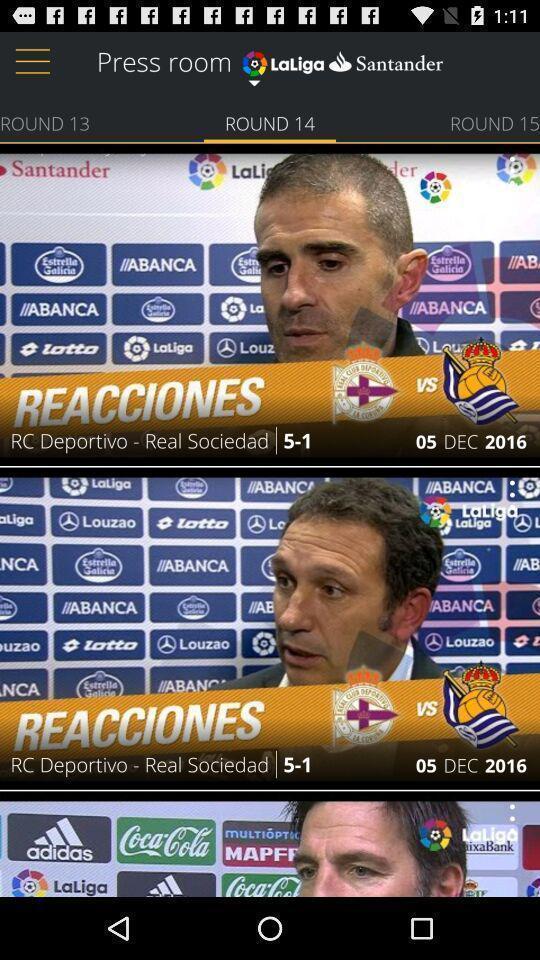Explain what's happening in this screen capture. Various articles displayed of a sports app. 